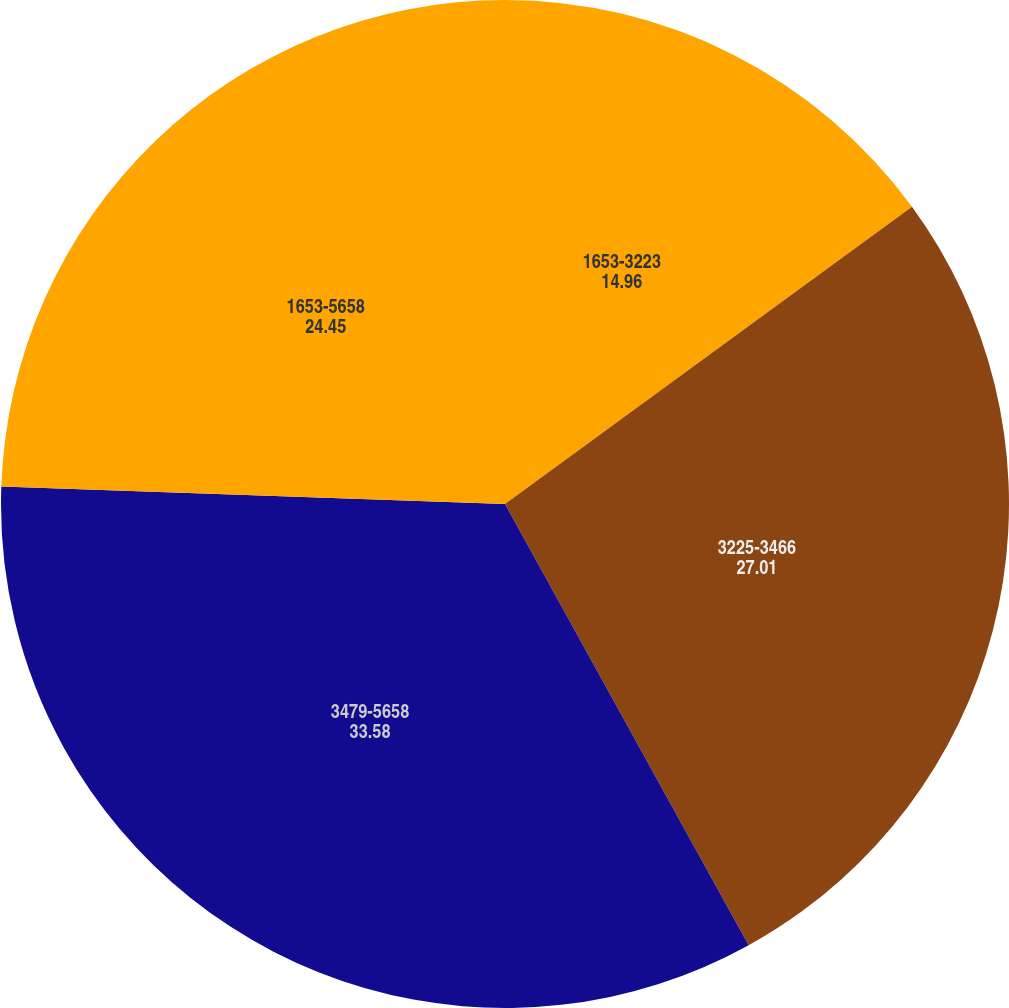<chart> <loc_0><loc_0><loc_500><loc_500><pie_chart><fcel>1653-3223<fcel>3225-3466<fcel>3479-5658<fcel>1653-5658<nl><fcel>14.96%<fcel>27.01%<fcel>33.58%<fcel>24.45%<nl></chart> 